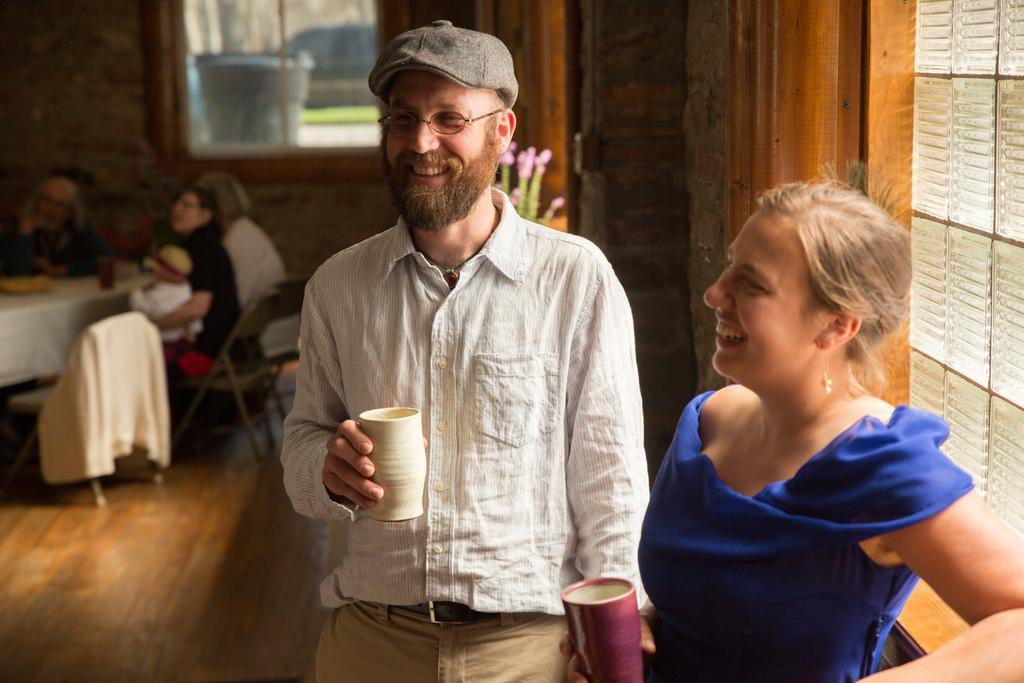Can you describe this image briefly? In this image I can see a man and a woman are standing. I can also see smile on their faces and both of them are holding glasses. I can see he is wearing a specs and a cap. In the background I can see few chairs and few more people. Here I can see a plant. 